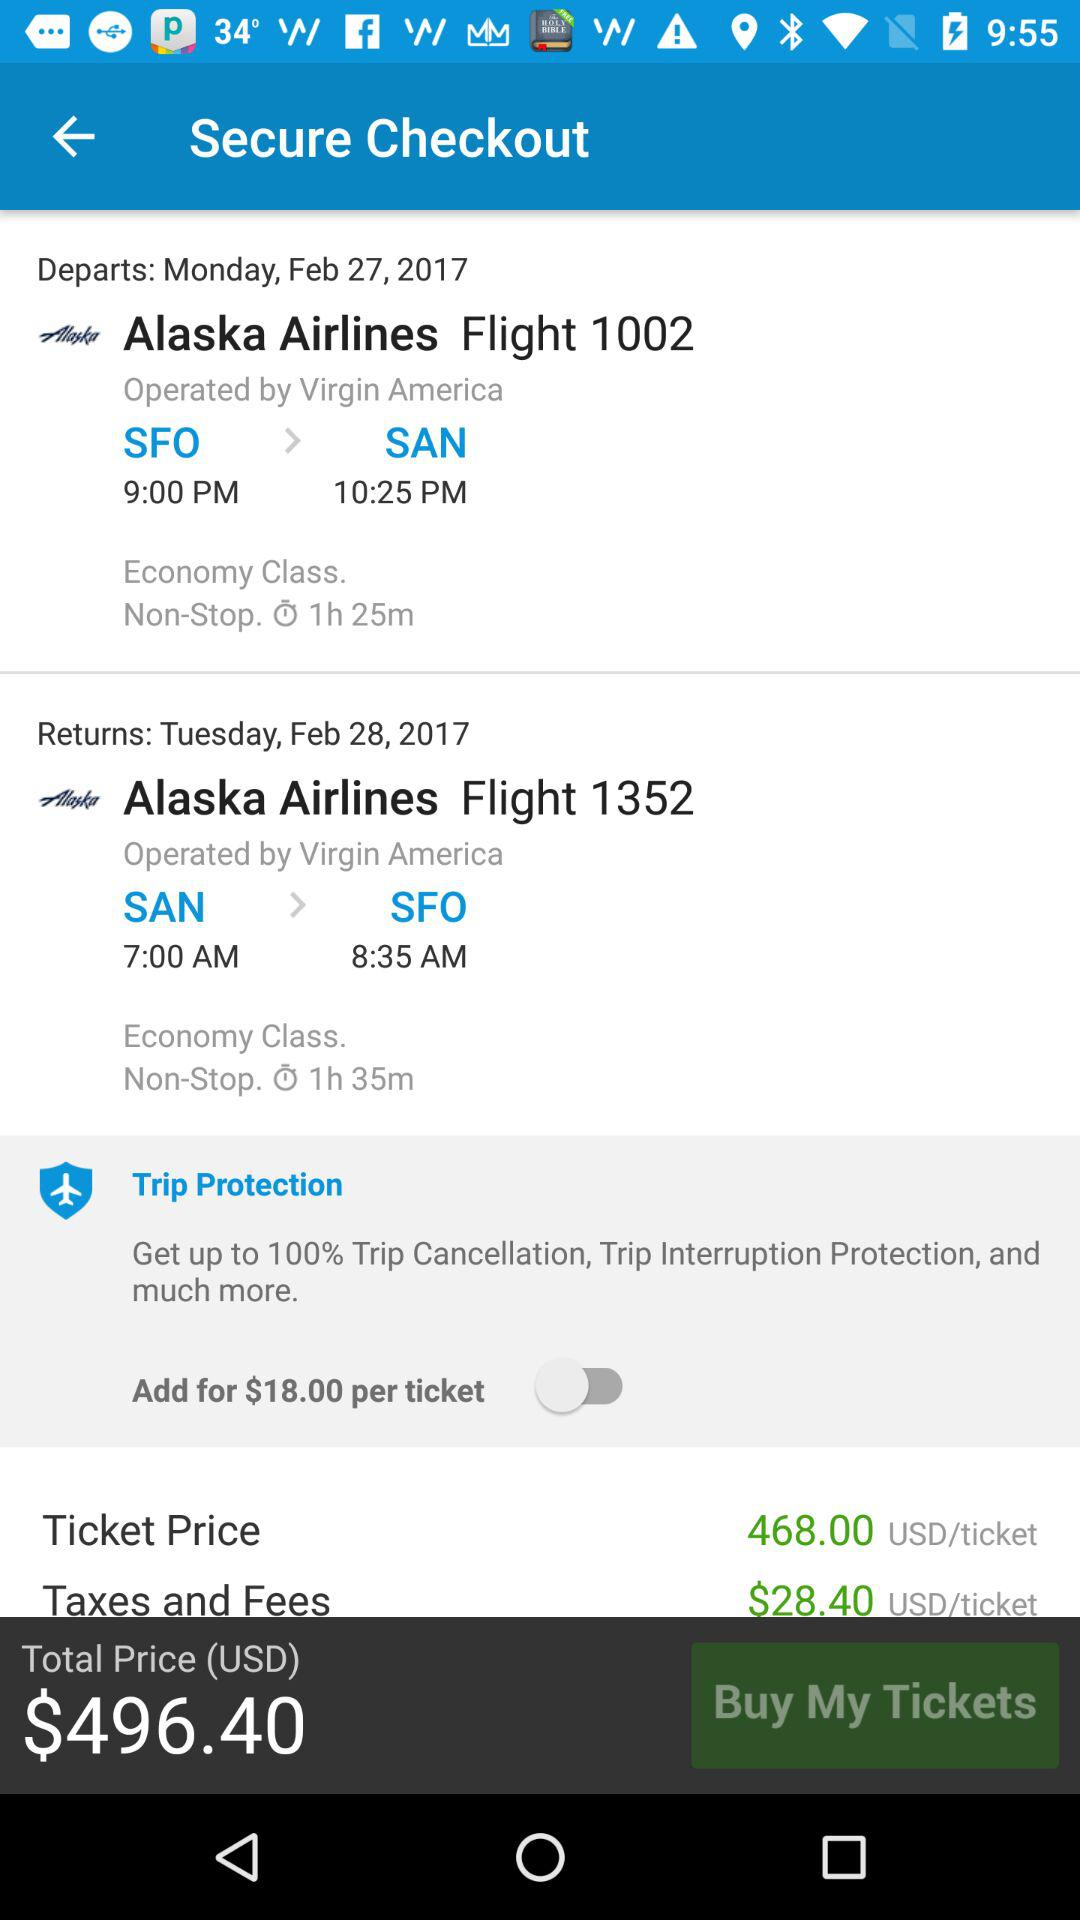What is the type of class for flight 1002? The class type for flight 1002 is economy. 